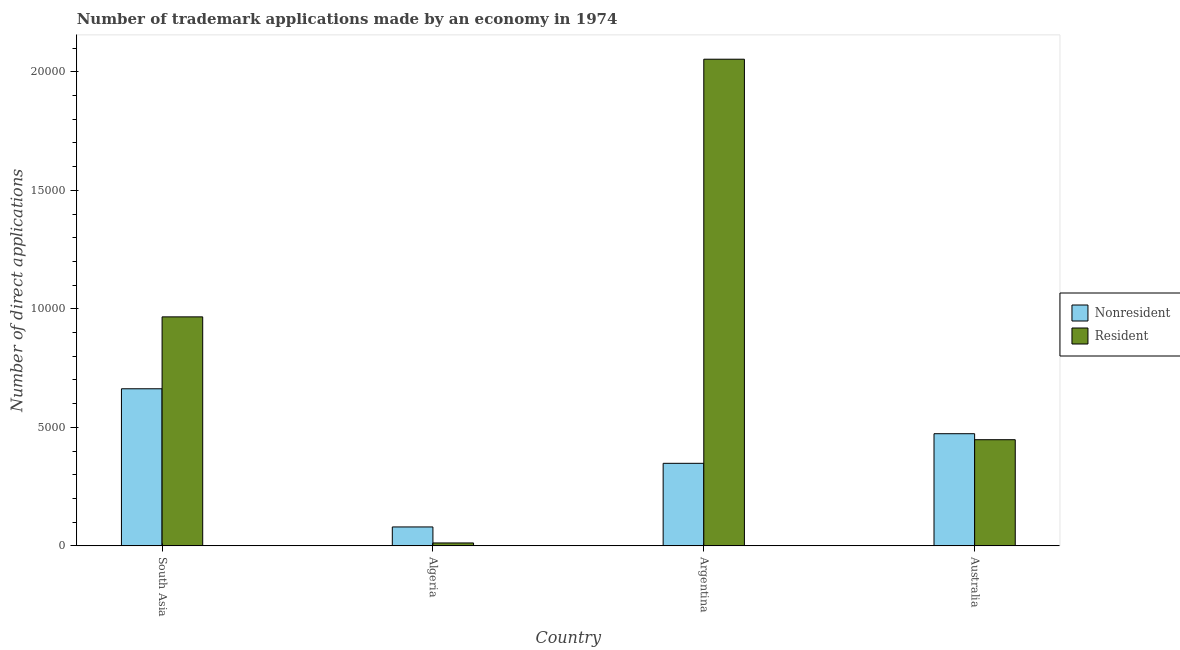How many different coloured bars are there?
Give a very brief answer. 2. How many groups of bars are there?
Offer a terse response. 4. Are the number of bars on each tick of the X-axis equal?
Offer a very short reply. Yes. How many bars are there on the 1st tick from the left?
Offer a terse response. 2. What is the label of the 4th group of bars from the left?
Give a very brief answer. Australia. In how many cases, is the number of bars for a given country not equal to the number of legend labels?
Offer a terse response. 0. What is the number of trademark applications made by non residents in Algeria?
Your response must be concise. 797. Across all countries, what is the maximum number of trademark applications made by residents?
Your answer should be very brief. 2.05e+04. Across all countries, what is the minimum number of trademark applications made by non residents?
Your response must be concise. 797. In which country was the number of trademark applications made by non residents minimum?
Keep it short and to the point. Algeria. What is the total number of trademark applications made by residents in the graph?
Offer a terse response. 3.48e+04. What is the difference between the number of trademark applications made by non residents in Argentina and that in South Asia?
Give a very brief answer. -3145. What is the difference between the number of trademark applications made by residents in Argentina and the number of trademark applications made by non residents in Algeria?
Ensure brevity in your answer.  1.97e+04. What is the average number of trademark applications made by non residents per country?
Keep it short and to the point. 3909.25. What is the difference between the number of trademark applications made by residents and number of trademark applications made by non residents in South Asia?
Offer a terse response. 3034. What is the ratio of the number of trademark applications made by non residents in Algeria to that in Australia?
Provide a short and direct response. 0.17. Is the difference between the number of trademark applications made by non residents in Argentina and South Asia greater than the difference between the number of trademark applications made by residents in Argentina and South Asia?
Offer a terse response. No. What is the difference between the highest and the second highest number of trademark applications made by residents?
Your response must be concise. 1.09e+04. What is the difference between the highest and the lowest number of trademark applications made by residents?
Offer a very short reply. 2.04e+04. In how many countries, is the number of trademark applications made by residents greater than the average number of trademark applications made by residents taken over all countries?
Provide a succinct answer. 2. What does the 2nd bar from the left in Argentina represents?
Make the answer very short. Resident. What does the 2nd bar from the right in Argentina represents?
Keep it short and to the point. Nonresident. Are all the bars in the graph horizontal?
Keep it short and to the point. No. How many countries are there in the graph?
Keep it short and to the point. 4. Does the graph contain grids?
Offer a very short reply. No. How are the legend labels stacked?
Offer a terse response. Vertical. What is the title of the graph?
Make the answer very short. Number of trademark applications made by an economy in 1974. Does "Fixed telephone" appear as one of the legend labels in the graph?
Offer a very short reply. No. What is the label or title of the Y-axis?
Provide a succinct answer. Number of direct applications. What is the Number of direct applications in Nonresident in South Asia?
Keep it short and to the point. 6627. What is the Number of direct applications of Resident in South Asia?
Your answer should be compact. 9661. What is the Number of direct applications in Nonresident in Algeria?
Ensure brevity in your answer.  797. What is the Number of direct applications in Resident in Algeria?
Make the answer very short. 122. What is the Number of direct applications in Nonresident in Argentina?
Give a very brief answer. 3482. What is the Number of direct applications of Resident in Argentina?
Ensure brevity in your answer.  2.05e+04. What is the Number of direct applications of Nonresident in Australia?
Your answer should be very brief. 4731. What is the Number of direct applications of Resident in Australia?
Provide a short and direct response. 4478. Across all countries, what is the maximum Number of direct applications of Nonresident?
Offer a very short reply. 6627. Across all countries, what is the maximum Number of direct applications in Resident?
Provide a succinct answer. 2.05e+04. Across all countries, what is the minimum Number of direct applications of Nonresident?
Ensure brevity in your answer.  797. Across all countries, what is the minimum Number of direct applications in Resident?
Keep it short and to the point. 122. What is the total Number of direct applications of Nonresident in the graph?
Your answer should be very brief. 1.56e+04. What is the total Number of direct applications in Resident in the graph?
Provide a succinct answer. 3.48e+04. What is the difference between the Number of direct applications in Nonresident in South Asia and that in Algeria?
Give a very brief answer. 5830. What is the difference between the Number of direct applications of Resident in South Asia and that in Algeria?
Provide a succinct answer. 9539. What is the difference between the Number of direct applications of Nonresident in South Asia and that in Argentina?
Give a very brief answer. 3145. What is the difference between the Number of direct applications of Resident in South Asia and that in Argentina?
Your answer should be very brief. -1.09e+04. What is the difference between the Number of direct applications in Nonresident in South Asia and that in Australia?
Give a very brief answer. 1896. What is the difference between the Number of direct applications in Resident in South Asia and that in Australia?
Provide a short and direct response. 5183. What is the difference between the Number of direct applications in Nonresident in Algeria and that in Argentina?
Offer a very short reply. -2685. What is the difference between the Number of direct applications of Resident in Algeria and that in Argentina?
Offer a very short reply. -2.04e+04. What is the difference between the Number of direct applications of Nonresident in Algeria and that in Australia?
Provide a succinct answer. -3934. What is the difference between the Number of direct applications of Resident in Algeria and that in Australia?
Your answer should be very brief. -4356. What is the difference between the Number of direct applications of Nonresident in Argentina and that in Australia?
Ensure brevity in your answer.  -1249. What is the difference between the Number of direct applications in Resident in Argentina and that in Australia?
Ensure brevity in your answer.  1.61e+04. What is the difference between the Number of direct applications in Nonresident in South Asia and the Number of direct applications in Resident in Algeria?
Your answer should be very brief. 6505. What is the difference between the Number of direct applications of Nonresident in South Asia and the Number of direct applications of Resident in Argentina?
Keep it short and to the point. -1.39e+04. What is the difference between the Number of direct applications in Nonresident in South Asia and the Number of direct applications in Resident in Australia?
Give a very brief answer. 2149. What is the difference between the Number of direct applications of Nonresident in Algeria and the Number of direct applications of Resident in Argentina?
Give a very brief answer. -1.97e+04. What is the difference between the Number of direct applications in Nonresident in Algeria and the Number of direct applications in Resident in Australia?
Your response must be concise. -3681. What is the difference between the Number of direct applications in Nonresident in Argentina and the Number of direct applications in Resident in Australia?
Your answer should be compact. -996. What is the average Number of direct applications in Nonresident per country?
Give a very brief answer. 3909.25. What is the average Number of direct applications in Resident per country?
Your answer should be compact. 8698.5. What is the difference between the Number of direct applications of Nonresident and Number of direct applications of Resident in South Asia?
Offer a very short reply. -3034. What is the difference between the Number of direct applications in Nonresident and Number of direct applications in Resident in Algeria?
Offer a terse response. 675. What is the difference between the Number of direct applications of Nonresident and Number of direct applications of Resident in Argentina?
Your response must be concise. -1.71e+04. What is the difference between the Number of direct applications in Nonresident and Number of direct applications in Resident in Australia?
Keep it short and to the point. 253. What is the ratio of the Number of direct applications of Nonresident in South Asia to that in Algeria?
Give a very brief answer. 8.31. What is the ratio of the Number of direct applications of Resident in South Asia to that in Algeria?
Offer a terse response. 79.19. What is the ratio of the Number of direct applications of Nonresident in South Asia to that in Argentina?
Your answer should be very brief. 1.9. What is the ratio of the Number of direct applications of Resident in South Asia to that in Argentina?
Make the answer very short. 0.47. What is the ratio of the Number of direct applications in Nonresident in South Asia to that in Australia?
Your answer should be very brief. 1.4. What is the ratio of the Number of direct applications of Resident in South Asia to that in Australia?
Your answer should be compact. 2.16. What is the ratio of the Number of direct applications of Nonresident in Algeria to that in Argentina?
Ensure brevity in your answer.  0.23. What is the ratio of the Number of direct applications in Resident in Algeria to that in Argentina?
Offer a terse response. 0.01. What is the ratio of the Number of direct applications of Nonresident in Algeria to that in Australia?
Keep it short and to the point. 0.17. What is the ratio of the Number of direct applications of Resident in Algeria to that in Australia?
Make the answer very short. 0.03. What is the ratio of the Number of direct applications in Nonresident in Argentina to that in Australia?
Make the answer very short. 0.74. What is the ratio of the Number of direct applications in Resident in Argentina to that in Australia?
Your answer should be compact. 4.59. What is the difference between the highest and the second highest Number of direct applications in Nonresident?
Your response must be concise. 1896. What is the difference between the highest and the second highest Number of direct applications in Resident?
Ensure brevity in your answer.  1.09e+04. What is the difference between the highest and the lowest Number of direct applications of Nonresident?
Keep it short and to the point. 5830. What is the difference between the highest and the lowest Number of direct applications in Resident?
Give a very brief answer. 2.04e+04. 